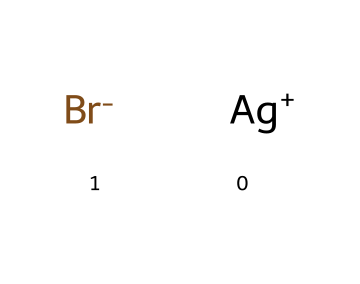What types of atoms are present in this chemical? The SMILES indicates the presence of silver (Ag) and bromine (Br) atoms. I can identify the elements by looking at the symbols present in the representation.
Answer: silver and bromine How many atoms are in this chemical? There are two types of atoms, silver (Ag) and bromine (Br), with one of each present, resulting in a total of two atoms.
Answer: two What is the charge on the silver atom in this compound? In the SMILES representation, the silver atom is indicated as [Ag+], which shows that it carries a positive charge.
Answer: positive What is the oxidation state of bromine in this chemical? The bromine atom is shown as [Br-], indicating it carries a negative charge, which corresponds to an oxidation state of -1.
Answer: -1 Why are silver halides used in photographic film? Silver halides are photoreactive chemicals that decompose when exposed to light, allowing for the formation of images on photographic film through the reduction of silver ions.
Answer: photoreactive What do the "+" and "-" signs indicate in this chemical structure? The "+" sign next to silver (Ag) denotes that it is a cation, while the "-" sign next to bromine (Br) denotes that it is an anion, showing their respective charges.
Answer: charges 